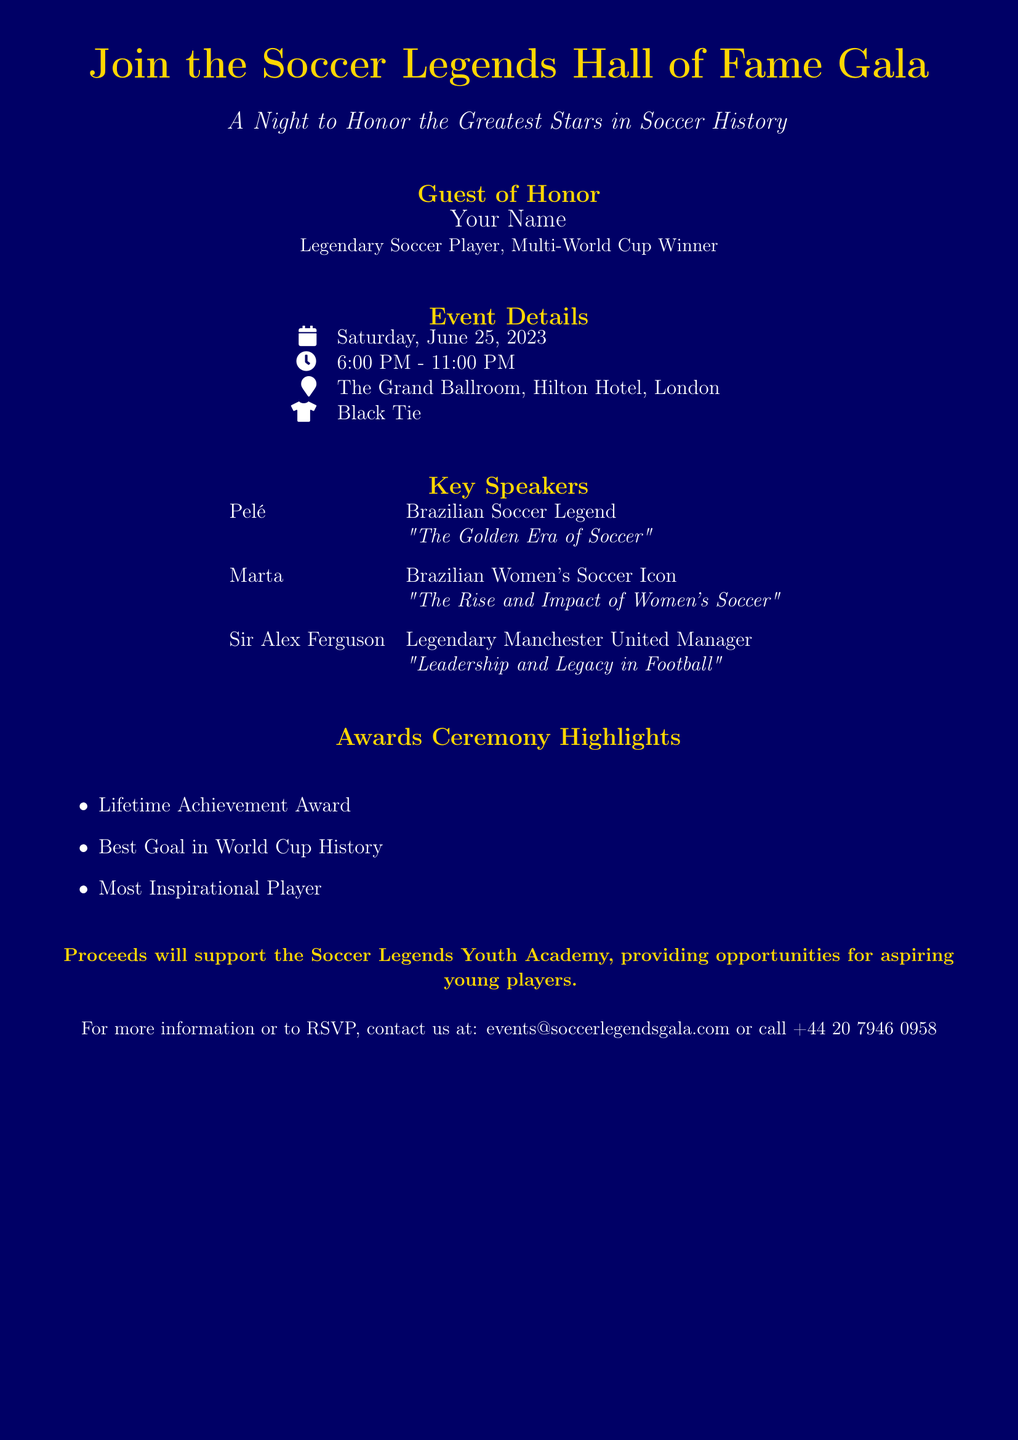What is the date of the event? The date of the event is listed under Event Details, denoting when the gala will take place.
Answer: Saturday, June 25, 2023 What is the location of the gala? The location of the gala is provided in the Event Details section, indicating where the event will be held.
Answer: The Grand Ballroom, Hilton Hotel, London Who is the Guest of Honor? The Guest of Honor is explicitly mentioned in the document, indicating the prominent individual attending the event.
Answer: Your Name What time does the gala start? The starting time of the gala is included in the Event Details, specifying when guests are to arrive.
Answer: 6:00 PM Which legendary player is speaking about "The Golden Era of Soccer"? The speakers are listed along with their topics, revealing who will discuss this aspect of soccer history.
Answer: Pelé What award will be given for the most inspirational player? The Awards Ceremony Highlights section lists the different awards to be presented at the gala, including this specific award.
Answer: Most Inspirational Player Which award refers to the best goal in World Cup history? The document details the awards being given, including this particular recognition for excellence in soccer.
Answer: Best Goal in World Cup History What is highlighted as a cause supported by the proceeds? The document mentions a specific initiative that will benefit from the event's proceeds, indicating the charitable aim behind the gala.
Answer: Soccer Legends Youth Academy Who will discuss "Leadership and Legacy in Football"? The speakers and their respective topics are outlined, revealing who will cover this subject during the event.
Answer: Sir Alex Ferguson 